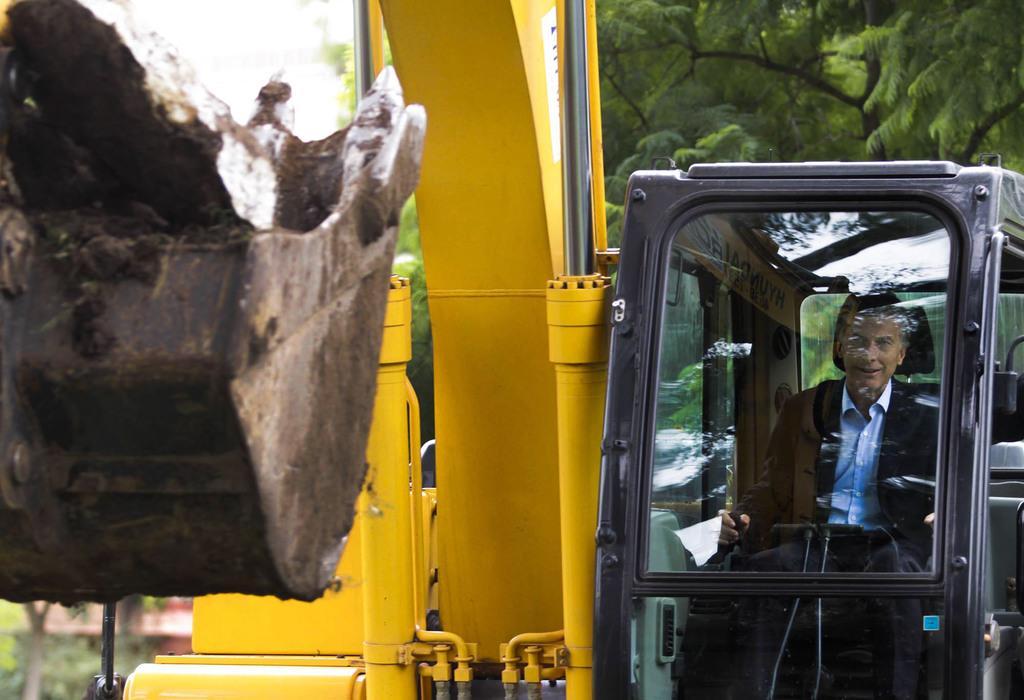How would you summarize this image in a sentence or two? In this picture there is a man who is sitting inside a vehicle on the right side of the image and there are trees in the background area of the image. 